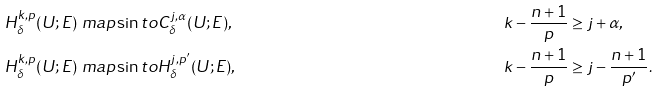<formula> <loc_0><loc_0><loc_500><loc_500>H ^ { k , p } _ { \delta } ( U ; E ) & \ m a p \sin t o C ^ { j , \alpha } _ { \delta } ( U ; E ) , & & k - \frac { n + 1 } { p } \geq j + \alpha , \\ H ^ { k , p } _ { \delta } ( U ; E ) & \ m a p \sin t o H ^ { j , p ^ { \prime } } _ { \delta } ( U ; E ) , & & k - \frac { n + 1 } { p } \geq j - \frac { n + 1 } { p ^ { \prime } } .</formula> 